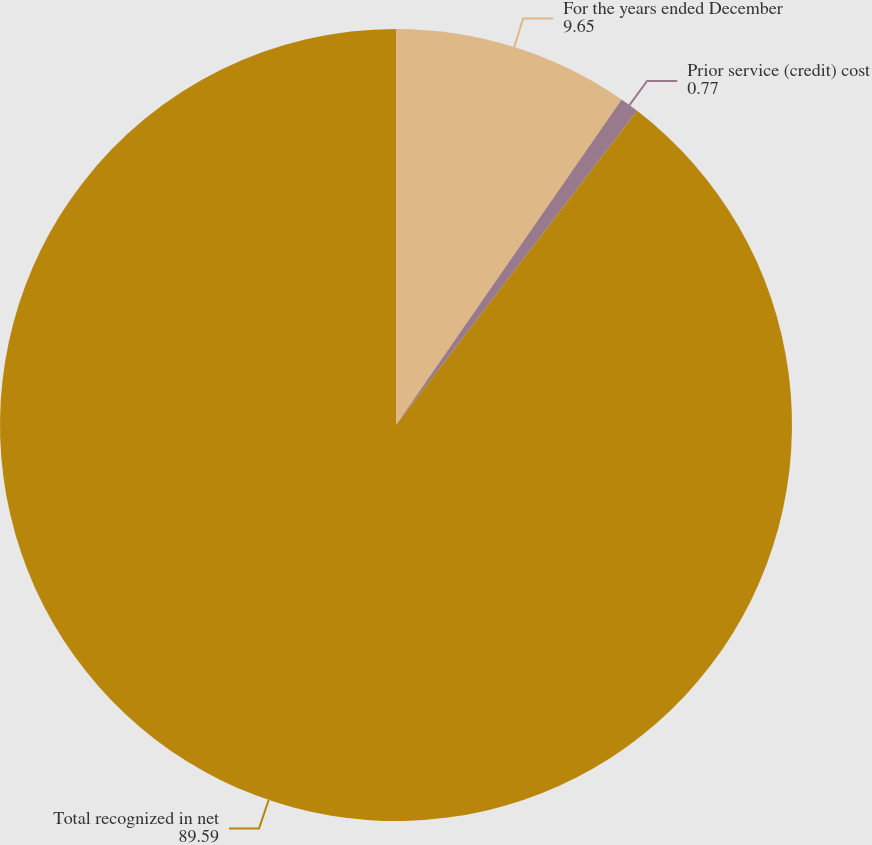<chart> <loc_0><loc_0><loc_500><loc_500><pie_chart><fcel>For the years ended December<fcel>Prior service (credit) cost<fcel>Total recognized in net<nl><fcel>9.65%<fcel>0.77%<fcel>89.59%<nl></chart> 